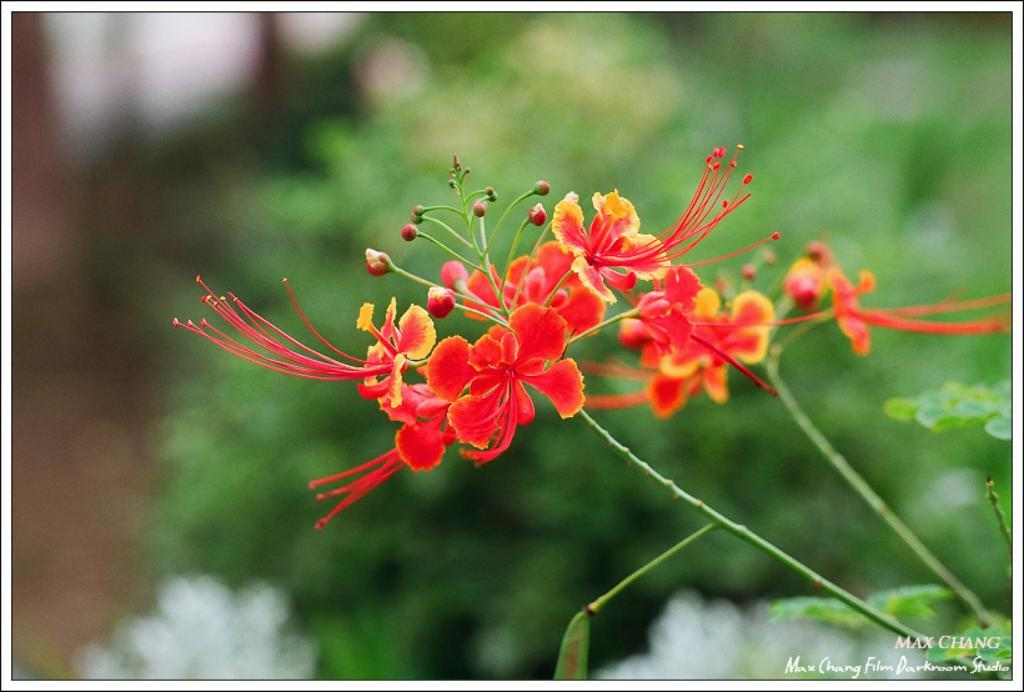What color are the plants in the foreground of the image? The plants in the foreground of the image are red. Can you describe the plants in the background of the image? There are additional plants in the background of the image, but their color is not specified. What type of wine can be seen in the image? There is no wine present in the image; it features plants. What type of twig is being used as a support for the plants in the image? There is no twig visible in the image; the plants are not shown to be supported by any specific object. 